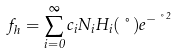<formula> <loc_0><loc_0><loc_500><loc_500>f _ { h } = \sum _ { i = 0 } ^ { \infty } c _ { i } N _ { i } H _ { i } ( \nu ) e ^ { - \nu ^ { 2 } }</formula> 